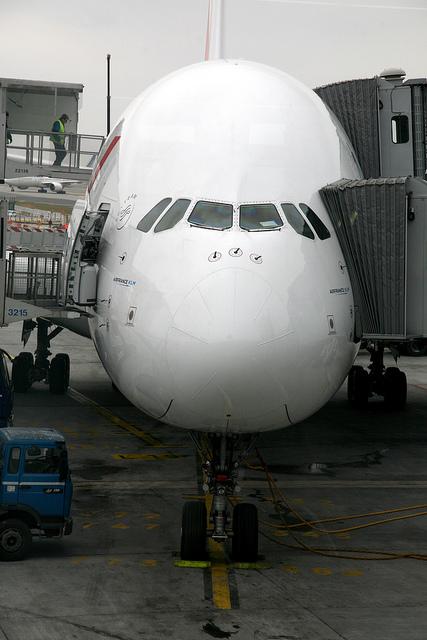What color is the plane?
Give a very brief answer. White. Is the plane about to take off?
Answer briefly. No. How many people can be seen in the picture?
Write a very short answer. 1. 